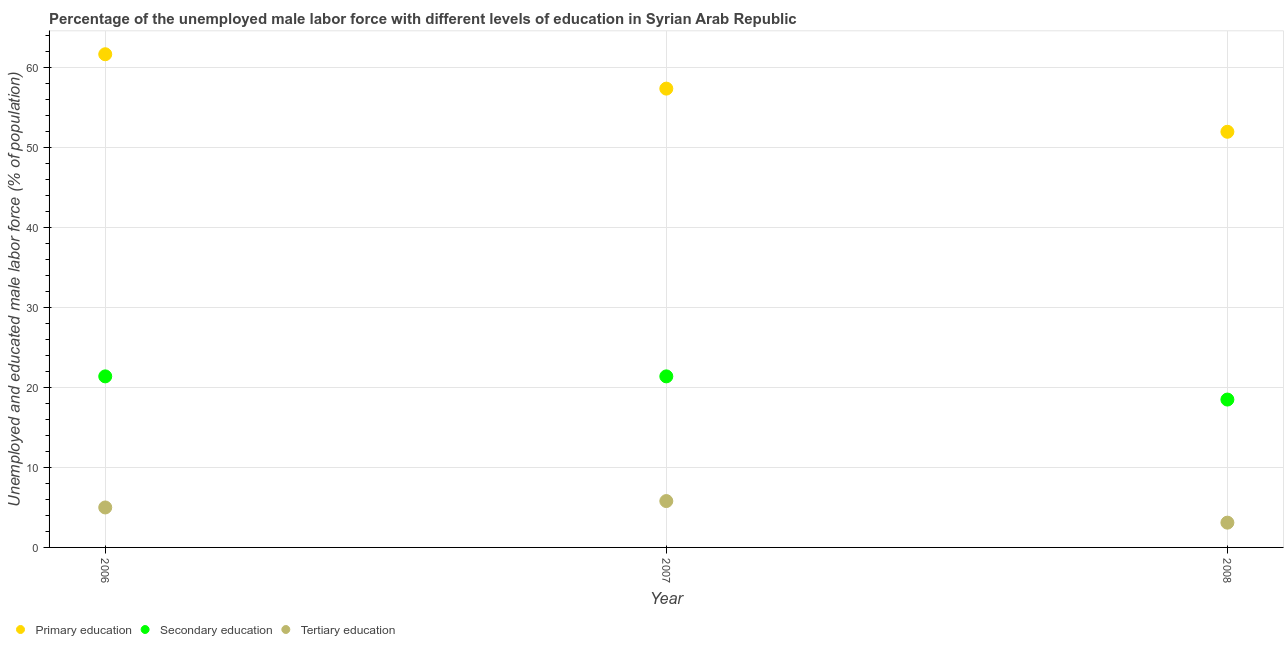What is the percentage of male labor force who received tertiary education in 2007?
Provide a short and direct response. 5.8. Across all years, what is the maximum percentage of male labor force who received primary education?
Provide a succinct answer. 61.7. Across all years, what is the minimum percentage of male labor force who received tertiary education?
Offer a very short reply. 3.1. In which year was the percentage of male labor force who received primary education maximum?
Offer a terse response. 2006. What is the total percentage of male labor force who received primary education in the graph?
Provide a succinct answer. 171.1. What is the difference between the percentage of male labor force who received secondary education in 2007 and that in 2008?
Keep it short and to the point. 2.9. What is the difference between the percentage of male labor force who received primary education in 2007 and the percentage of male labor force who received tertiary education in 2008?
Provide a succinct answer. 54.3. What is the average percentage of male labor force who received tertiary education per year?
Provide a succinct answer. 4.63. In the year 2007, what is the difference between the percentage of male labor force who received primary education and percentage of male labor force who received tertiary education?
Offer a terse response. 51.6. What is the ratio of the percentage of male labor force who received secondary education in 2007 to that in 2008?
Offer a terse response. 1.16. Is the percentage of male labor force who received tertiary education in 2006 less than that in 2008?
Your response must be concise. No. What is the difference between the highest and the second highest percentage of male labor force who received primary education?
Your answer should be compact. 4.3. What is the difference between the highest and the lowest percentage of male labor force who received primary education?
Your response must be concise. 9.7. In how many years, is the percentage of male labor force who received tertiary education greater than the average percentage of male labor force who received tertiary education taken over all years?
Your answer should be compact. 2. Is the sum of the percentage of male labor force who received secondary education in 2006 and 2007 greater than the maximum percentage of male labor force who received tertiary education across all years?
Offer a very short reply. Yes. Is the percentage of male labor force who received primary education strictly greater than the percentage of male labor force who received secondary education over the years?
Make the answer very short. Yes. What is the difference between two consecutive major ticks on the Y-axis?
Your answer should be very brief. 10. Does the graph contain any zero values?
Offer a very short reply. No. Does the graph contain grids?
Your response must be concise. Yes. What is the title of the graph?
Offer a very short reply. Percentage of the unemployed male labor force with different levels of education in Syrian Arab Republic. What is the label or title of the Y-axis?
Provide a short and direct response. Unemployed and educated male labor force (% of population). What is the Unemployed and educated male labor force (% of population) of Primary education in 2006?
Your answer should be very brief. 61.7. What is the Unemployed and educated male labor force (% of population) of Secondary education in 2006?
Offer a terse response. 21.4. What is the Unemployed and educated male labor force (% of population) in Tertiary education in 2006?
Offer a very short reply. 5. What is the Unemployed and educated male labor force (% of population) in Primary education in 2007?
Your answer should be very brief. 57.4. What is the Unemployed and educated male labor force (% of population) in Secondary education in 2007?
Make the answer very short. 21.4. What is the Unemployed and educated male labor force (% of population) in Tertiary education in 2007?
Ensure brevity in your answer.  5.8. What is the Unemployed and educated male labor force (% of population) of Primary education in 2008?
Give a very brief answer. 52. What is the Unemployed and educated male labor force (% of population) in Secondary education in 2008?
Provide a succinct answer. 18.5. What is the Unemployed and educated male labor force (% of population) of Tertiary education in 2008?
Offer a very short reply. 3.1. Across all years, what is the maximum Unemployed and educated male labor force (% of population) in Primary education?
Offer a terse response. 61.7. Across all years, what is the maximum Unemployed and educated male labor force (% of population) in Secondary education?
Provide a short and direct response. 21.4. Across all years, what is the maximum Unemployed and educated male labor force (% of population) in Tertiary education?
Ensure brevity in your answer.  5.8. Across all years, what is the minimum Unemployed and educated male labor force (% of population) in Secondary education?
Your answer should be compact. 18.5. Across all years, what is the minimum Unemployed and educated male labor force (% of population) in Tertiary education?
Offer a terse response. 3.1. What is the total Unemployed and educated male labor force (% of population) in Primary education in the graph?
Ensure brevity in your answer.  171.1. What is the total Unemployed and educated male labor force (% of population) of Secondary education in the graph?
Your answer should be compact. 61.3. What is the difference between the Unemployed and educated male labor force (% of population) in Secondary education in 2006 and that in 2007?
Offer a very short reply. 0. What is the difference between the Unemployed and educated male labor force (% of population) in Secondary education in 2006 and that in 2008?
Offer a very short reply. 2.9. What is the difference between the Unemployed and educated male labor force (% of population) of Primary education in 2007 and that in 2008?
Your answer should be very brief. 5.4. What is the difference between the Unemployed and educated male labor force (% of population) in Primary education in 2006 and the Unemployed and educated male labor force (% of population) in Secondary education in 2007?
Give a very brief answer. 40.3. What is the difference between the Unemployed and educated male labor force (% of population) of Primary education in 2006 and the Unemployed and educated male labor force (% of population) of Tertiary education in 2007?
Your answer should be very brief. 55.9. What is the difference between the Unemployed and educated male labor force (% of population) of Secondary education in 2006 and the Unemployed and educated male labor force (% of population) of Tertiary education in 2007?
Give a very brief answer. 15.6. What is the difference between the Unemployed and educated male labor force (% of population) of Primary education in 2006 and the Unemployed and educated male labor force (% of population) of Secondary education in 2008?
Provide a succinct answer. 43.2. What is the difference between the Unemployed and educated male labor force (% of population) of Primary education in 2006 and the Unemployed and educated male labor force (% of population) of Tertiary education in 2008?
Offer a terse response. 58.6. What is the difference between the Unemployed and educated male labor force (% of population) in Secondary education in 2006 and the Unemployed and educated male labor force (% of population) in Tertiary education in 2008?
Make the answer very short. 18.3. What is the difference between the Unemployed and educated male labor force (% of population) in Primary education in 2007 and the Unemployed and educated male labor force (% of population) in Secondary education in 2008?
Your answer should be compact. 38.9. What is the difference between the Unemployed and educated male labor force (% of population) of Primary education in 2007 and the Unemployed and educated male labor force (% of population) of Tertiary education in 2008?
Your response must be concise. 54.3. What is the average Unemployed and educated male labor force (% of population) in Primary education per year?
Make the answer very short. 57.03. What is the average Unemployed and educated male labor force (% of population) in Secondary education per year?
Provide a short and direct response. 20.43. What is the average Unemployed and educated male labor force (% of population) of Tertiary education per year?
Ensure brevity in your answer.  4.63. In the year 2006, what is the difference between the Unemployed and educated male labor force (% of population) in Primary education and Unemployed and educated male labor force (% of population) in Secondary education?
Keep it short and to the point. 40.3. In the year 2006, what is the difference between the Unemployed and educated male labor force (% of population) in Primary education and Unemployed and educated male labor force (% of population) in Tertiary education?
Offer a very short reply. 56.7. In the year 2006, what is the difference between the Unemployed and educated male labor force (% of population) in Secondary education and Unemployed and educated male labor force (% of population) in Tertiary education?
Your answer should be very brief. 16.4. In the year 2007, what is the difference between the Unemployed and educated male labor force (% of population) in Primary education and Unemployed and educated male labor force (% of population) in Tertiary education?
Keep it short and to the point. 51.6. In the year 2007, what is the difference between the Unemployed and educated male labor force (% of population) of Secondary education and Unemployed and educated male labor force (% of population) of Tertiary education?
Ensure brevity in your answer.  15.6. In the year 2008, what is the difference between the Unemployed and educated male labor force (% of population) in Primary education and Unemployed and educated male labor force (% of population) in Secondary education?
Make the answer very short. 33.5. In the year 2008, what is the difference between the Unemployed and educated male labor force (% of population) of Primary education and Unemployed and educated male labor force (% of population) of Tertiary education?
Ensure brevity in your answer.  48.9. What is the ratio of the Unemployed and educated male labor force (% of population) of Primary education in 2006 to that in 2007?
Your response must be concise. 1.07. What is the ratio of the Unemployed and educated male labor force (% of population) of Secondary education in 2006 to that in 2007?
Provide a succinct answer. 1. What is the ratio of the Unemployed and educated male labor force (% of population) in Tertiary education in 2006 to that in 2007?
Your answer should be very brief. 0.86. What is the ratio of the Unemployed and educated male labor force (% of population) in Primary education in 2006 to that in 2008?
Give a very brief answer. 1.19. What is the ratio of the Unemployed and educated male labor force (% of population) in Secondary education in 2006 to that in 2008?
Your response must be concise. 1.16. What is the ratio of the Unemployed and educated male labor force (% of population) of Tertiary education in 2006 to that in 2008?
Offer a very short reply. 1.61. What is the ratio of the Unemployed and educated male labor force (% of population) of Primary education in 2007 to that in 2008?
Your response must be concise. 1.1. What is the ratio of the Unemployed and educated male labor force (% of population) of Secondary education in 2007 to that in 2008?
Give a very brief answer. 1.16. What is the ratio of the Unemployed and educated male labor force (% of population) of Tertiary education in 2007 to that in 2008?
Make the answer very short. 1.87. What is the difference between the highest and the second highest Unemployed and educated male labor force (% of population) in Primary education?
Provide a short and direct response. 4.3. What is the difference between the highest and the lowest Unemployed and educated male labor force (% of population) of Primary education?
Your answer should be compact. 9.7. 